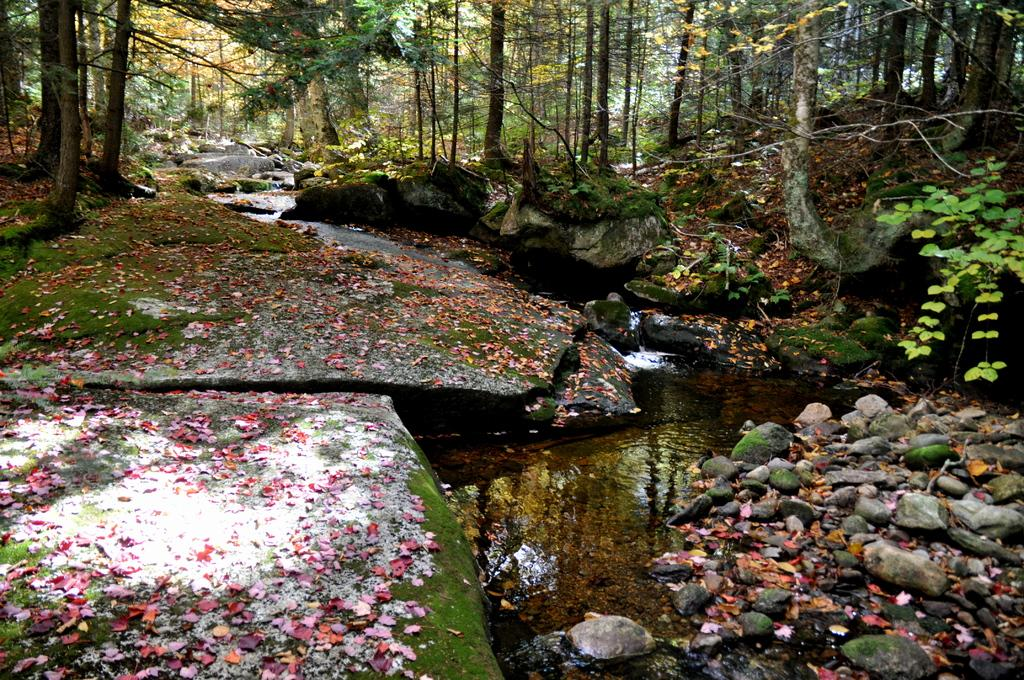What type of vegetation can be seen in the image? There are trees in the image. What part of the trees can be seen in the image? Leaves are present in the image. What type of natural elements can be seen in the image? Rocks and stones are visible in the image. What is the liquid element visible in the image? There is water visible in the image. What is the weight of the way in the image? There is no "way" present in the image, and therefore, it is not possible to determine its weight. 